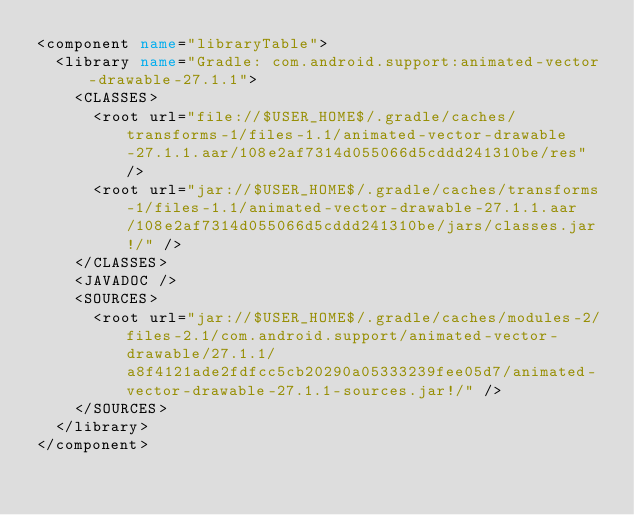<code> <loc_0><loc_0><loc_500><loc_500><_XML_><component name="libraryTable">
  <library name="Gradle: com.android.support:animated-vector-drawable-27.1.1">
    <CLASSES>
      <root url="file://$USER_HOME$/.gradle/caches/transforms-1/files-1.1/animated-vector-drawable-27.1.1.aar/108e2af7314d055066d5cddd241310be/res" />
      <root url="jar://$USER_HOME$/.gradle/caches/transforms-1/files-1.1/animated-vector-drawable-27.1.1.aar/108e2af7314d055066d5cddd241310be/jars/classes.jar!/" />
    </CLASSES>
    <JAVADOC />
    <SOURCES>
      <root url="jar://$USER_HOME$/.gradle/caches/modules-2/files-2.1/com.android.support/animated-vector-drawable/27.1.1/a8f4121ade2fdfcc5cb20290a05333239fee05d7/animated-vector-drawable-27.1.1-sources.jar!/" />
    </SOURCES>
  </library>
</component></code> 